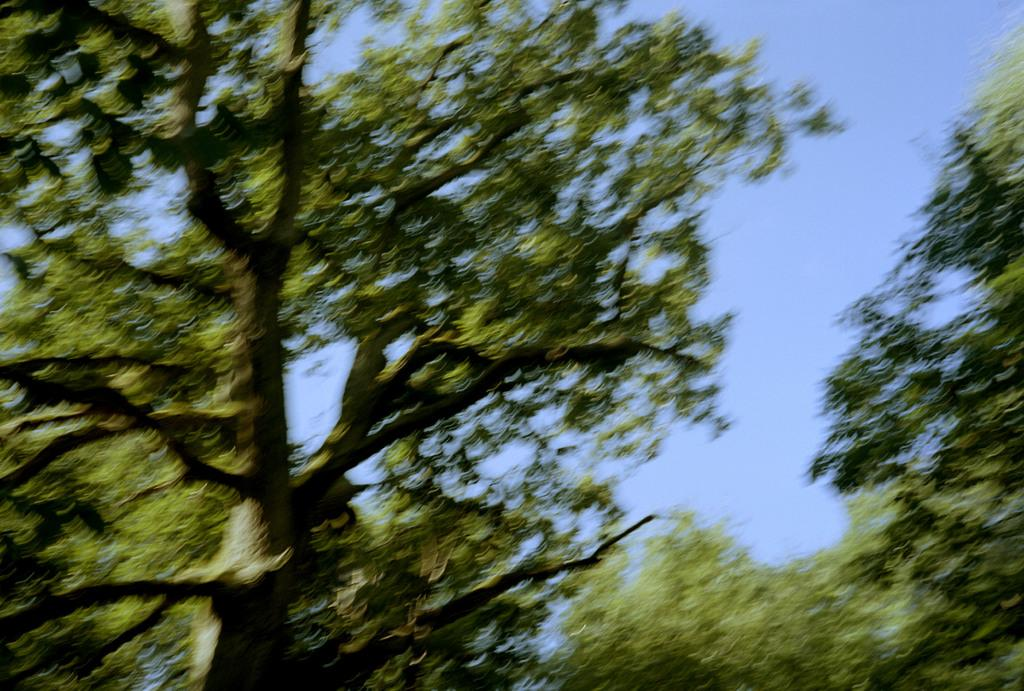What type of vegetation is visible in the front of the image? There are trees in the front of the image. What part of the natural environment is visible in the background of the image? The sky is visible in the background of the image. What type of face can be seen in the image? There is no face present in the image; it features trees in the front and the sky in the background. 